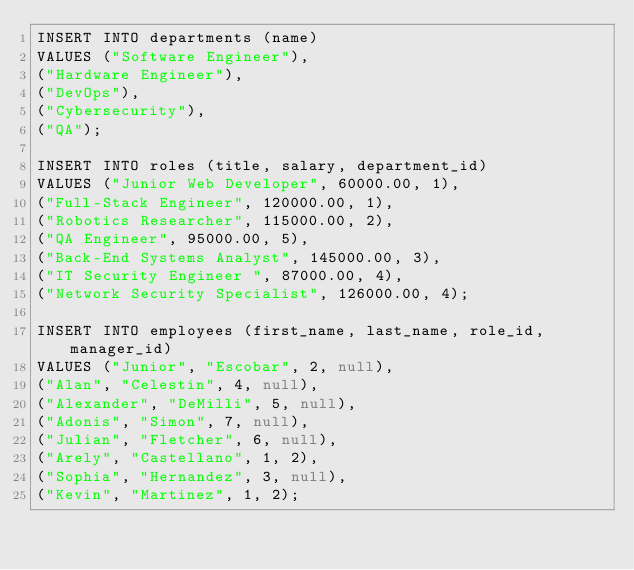<code> <loc_0><loc_0><loc_500><loc_500><_SQL_>INSERT INTO departments (name)
VALUES ("Software Engineer"),
("Hardware Engineer"),
("DevOps"),
("Cybersecurity"),
("QA");

INSERT INTO roles (title, salary, department_id)
VALUES ("Junior Web Developer", 60000.00, 1),
("Full-Stack Engineer", 120000.00, 1),
("Robotics Researcher", 115000.00, 2),
("QA Engineer", 95000.00, 5),
("Back-End Systems Analyst", 145000.00, 3),
("IT Security Engineer ", 87000.00, 4),
("Network Security Specialist", 126000.00, 4);

INSERT INTO employees (first_name, last_name, role_id, manager_id)
VALUES ("Junior", "Escobar", 2, null),
("Alan", "Celestin", 4, null),
("Alexander", "DeMilli", 5, null),
("Adonis", "Simon", 7, null),
("Julian", "Fletcher", 6, null),
("Arely", "Castellano", 1, 2),
("Sophia", "Hernandez", 3, null),
("Kevin", "Martinez", 1, 2);

</code> 